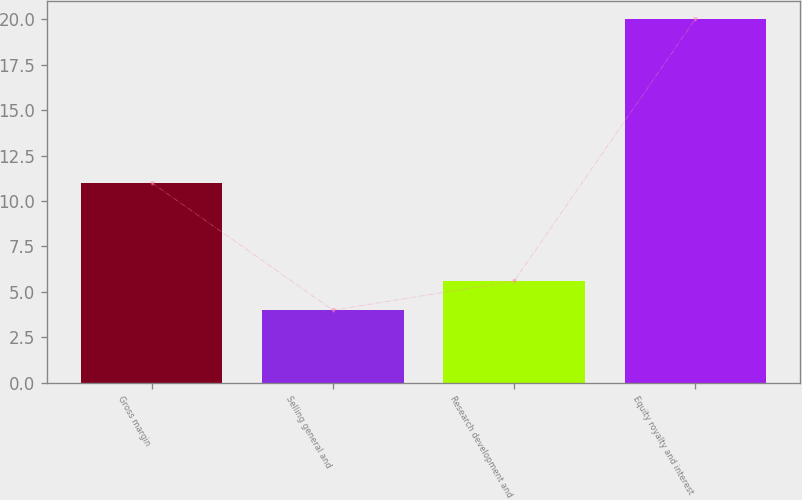Convert chart to OTSL. <chart><loc_0><loc_0><loc_500><loc_500><bar_chart><fcel>Gross margin<fcel>Selling general and<fcel>Research development and<fcel>Equity royalty and interest<nl><fcel>11<fcel>4<fcel>5.6<fcel>20<nl></chart> 